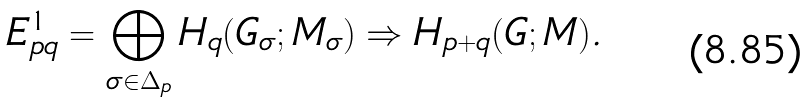Convert formula to latex. <formula><loc_0><loc_0><loc_500><loc_500>E ^ { 1 } _ { p q } = \bigoplus _ { \sigma \in \Delta _ { p } } H _ { q } ( G _ { \sigma } ; M _ { \sigma } ) \Rightarrow H _ { p + q } ( G ; M ) .</formula> 